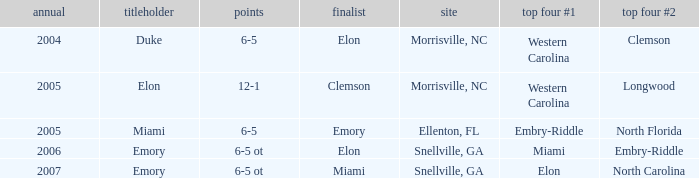Which team was the second semi finalist in 2007? North Carolina. 